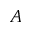<formula> <loc_0><loc_0><loc_500><loc_500>A</formula> 